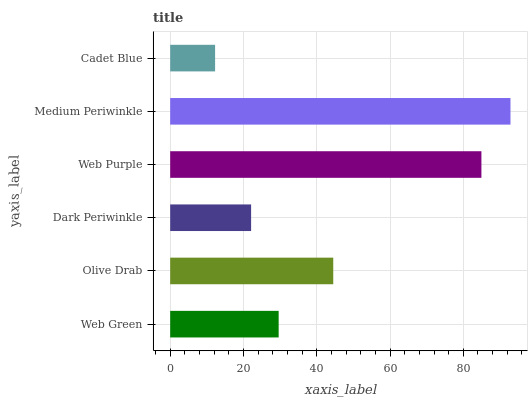Is Cadet Blue the minimum?
Answer yes or no. Yes. Is Medium Periwinkle the maximum?
Answer yes or no. Yes. Is Olive Drab the minimum?
Answer yes or no. No. Is Olive Drab the maximum?
Answer yes or no. No. Is Olive Drab greater than Web Green?
Answer yes or no. Yes. Is Web Green less than Olive Drab?
Answer yes or no. Yes. Is Web Green greater than Olive Drab?
Answer yes or no. No. Is Olive Drab less than Web Green?
Answer yes or no. No. Is Olive Drab the high median?
Answer yes or no. Yes. Is Web Green the low median?
Answer yes or no. Yes. Is Web Purple the high median?
Answer yes or no. No. Is Olive Drab the low median?
Answer yes or no. No. 